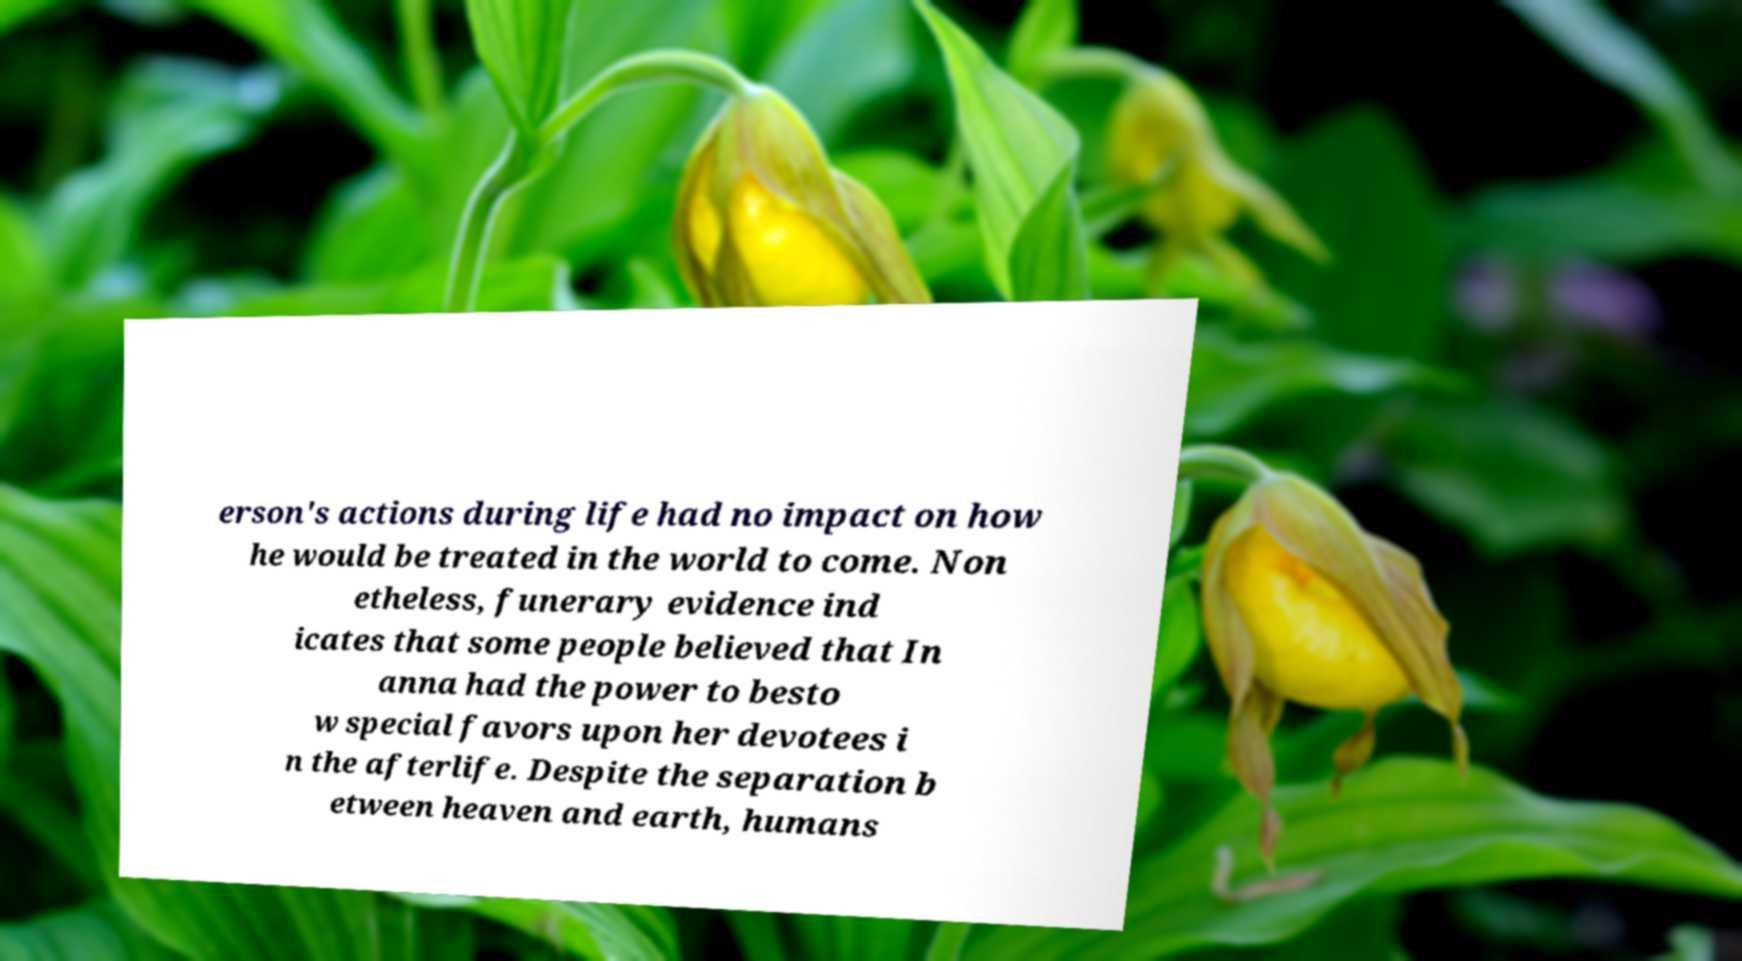What messages or text are displayed in this image? I need them in a readable, typed format. erson's actions during life had no impact on how he would be treated in the world to come. Non etheless, funerary evidence ind icates that some people believed that In anna had the power to besto w special favors upon her devotees i n the afterlife. Despite the separation b etween heaven and earth, humans 